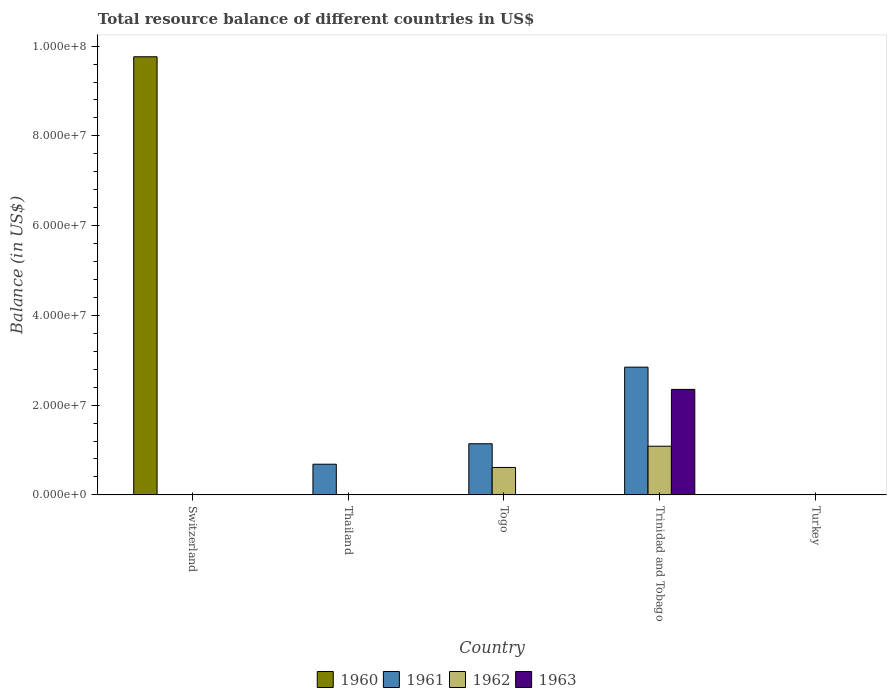How many different coloured bars are there?
Make the answer very short. 4. Are the number of bars per tick equal to the number of legend labels?
Give a very brief answer. No. How many bars are there on the 3rd tick from the left?
Offer a terse response. 2. How many bars are there on the 1st tick from the right?
Your answer should be compact. 0. What is the label of the 4th group of bars from the left?
Your response must be concise. Trinidad and Tobago. In how many cases, is the number of bars for a given country not equal to the number of legend labels?
Offer a very short reply. 5. What is the total resource balance in 1962 in Turkey?
Keep it short and to the point. 0. Across all countries, what is the maximum total resource balance in 1961?
Keep it short and to the point. 2.85e+07. In which country was the total resource balance in 1962 maximum?
Make the answer very short. Trinidad and Tobago. What is the total total resource balance in 1963 in the graph?
Offer a very short reply. 2.35e+07. What is the difference between the total resource balance in 1962 in Togo and that in Trinidad and Tobago?
Your answer should be very brief. -4.74e+06. What is the average total resource balance in 1961 per country?
Ensure brevity in your answer.  9.34e+06. What is the difference between the highest and the second highest total resource balance in 1961?
Provide a short and direct response. -4.56e+06. What is the difference between the highest and the lowest total resource balance in 1962?
Ensure brevity in your answer.  1.08e+07. Is it the case that in every country, the sum of the total resource balance in 1961 and total resource balance in 1963 is greater than the sum of total resource balance in 1962 and total resource balance in 1960?
Provide a short and direct response. No. Is it the case that in every country, the sum of the total resource balance in 1960 and total resource balance in 1961 is greater than the total resource balance in 1963?
Provide a short and direct response. No. How many bars are there?
Your answer should be very brief. 7. How many countries are there in the graph?
Ensure brevity in your answer.  5. Are the values on the major ticks of Y-axis written in scientific E-notation?
Your response must be concise. Yes. Does the graph contain grids?
Your answer should be compact. No. How many legend labels are there?
Give a very brief answer. 4. How are the legend labels stacked?
Your response must be concise. Horizontal. What is the title of the graph?
Your answer should be very brief. Total resource balance of different countries in US$. What is the label or title of the X-axis?
Offer a terse response. Country. What is the label or title of the Y-axis?
Your answer should be very brief. Balance (in US$). What is the Balance (in US$) in 1960 in Switzerland?
Give a very brief answer. 9.76e+07. What is the Balance (in US$) of 1961 in Switzerland?
Provide a succinct answer. 0. What is the Balance (in US$) of 1961 in Thailand?
Your answer should be very brief. 6.84e+06. What is the Balance (in US$) of 1961 in Togo?
Your answer should be compact. 1.14e+07. What is the Balance (in US$) in 1962 in Togo?
Provide a succinct answer. 6.11e+06. What is the Balance (in US$) of 1961 in Trinidad and Tobago?
Make the answer very short. 2.85e+07. What is the Balance (in US$) of 1962 in Trinidad and Tobago?
Your response must be concise. 1.08e+07. What is the Balance (in US$) of 1963 in Trinidad and Tobago?
Your answer should be compact. 2.35e+07. What is the Balance (in US$) of 1961 in Turkey?
Offer a very short reply. 0. What is the Balance (in US$) in 1963 in Turkey?
Make the answer very short. 0. Across all countries, what is the maximum Balance (in US$) of 1960?
Your answer should be very brief. 9.76e+07. Across all countries, what is the maximum Balance (in US$) of 1961?
Provide a short and direct response. 2.85e+07. Across all countries, what is the maximum Balance (in US$) in 1962?
Provide a short and direct response. 1.08e+07. Across all countries, what is the maximum Balance (in US$) in 1963?
Offer a terse response. 2.35e+07. Across all countries, what is the minimum Balance (in US$) of 1960?
Give a very brief answer. 0. Across all countries, what is the minimum Balance (in US$) in 1962?
Your answer should be very brief. 0. What is the total Balance (in US$) of 1960 in the graph?
Your answer should be compact. 9.76e+07. What is the total Balance (in US$) in 1961 in the graph?
Provide a succinct answer. 4.67e+07. What is the total Balance (in US$) in 1962 in the graph?
Your answer should be very brief. 1.70e+07. What is the total Balance (in US$) of 1963 in the graph?
Make the answer very short. 2.35e+07. What is the difference between the Balance (in US$) of 1961 in Thailand and that in Togo?
Offer a terse response. -4.56e+06. What is the difference between the Balance (in US$) of 1961 in Thailand and that in Trinidad and Tobago?
Your answer should be very brief. -2.16e+07. What is the difference between the Balance (in US$) in 1961 in Togo and that in Trinidad and Tobago?
Provide a succinct answer. -1.71e+07. What is the difference between the Balance (in US$) in 1962 in Togo and that in Trinidad and Tobago?
Keep it short and to the point. -4.74e+06. What is the difference between the Balance (in US$) in 1960 in Switzerland and the Balance (in US$) in 1961 in Thailand?
Give a very brief answer. 9.08e+07. What is the difference between the Balance (in US$) of 1960 in Switzerland and the Balance (in US$) of 1961 in Togo?
Ensure brevity in your answer.  8.62e+07. What is the difference between the Balance (in US$) of 1960 in Switzerland and the Balance (in US$) of 1962 in Togo?
Provide a succinct answer. 9.15e+07. What is the difference between the Balance (in US$) of 1960 in Switzerland and the Balance (in US$) of 1961 in Trinidad and Tobago?
Make the answer very short. 6.92e+07. What is the difference between the Balance (in US$) of 1960 in Switzerland and the Balance (in US$) of 1962 in Trinidad and Tobago?
Your answer should be very brief. 8.68e+07. What is the difference between the Balance (in US$) in 1960 in Switzerland and the Balance (in US$) in 1963 in Trinidad and Tobago?
Your response must be concise. 7.41e+07. What is the difference between the Balance (in US$) of 1961 in Thailand and the Balance (in US$) of 1962 in Togo?
Give a very brief answer. 7.25e+05. What is the difference between the Balance (in US$) in 1961 in Thailand and the Balance (in US$) in 1962 in Trinidad and Tobago?
Your answer should be very brief. -4.01e+06. What is the difference between the Balance (in US$) in 1961 in Thailand and the Balance (in US$) in 1963 in Trinidad and Tobago?
Offer a very short reply. -1.67e+07. What is the difference between the Balance (in US$) in 1961 in Togo and the Balance (in US$) in 1962 in Trinidad and Tobago?
Provide a succinct answer. 5.50e+05. What is the difference between the Balance (in US$) of 1961 in Togo and the Balance (in US$) of 1963 in Trinidad and Tobago?
Make the answer very short. -1.21e+07. What is the difference between the Balance (in US$) of 1962 in Togo and the Balance (in US$) of 1963 in Trinidad and Tobago?
Give a very brief answer. -1.74e+07. What is the average Balance (in US$) in 1960 per country?
Provide a succinct answer. 1.95e+07. What is the average Balance (in US$) in 1961 per country?
Provide a short and direct response. 9.34e+06. What is the average Balance (in US$) of 1962 per country?
Your answer should be compact. 3.39e+06. What is the average Balance (in US$) in 1963 per country?
Your answer should be compact. 4.70e+06. What is the difference between the Balance (in US$) of 1961 and Balance (in US$) of 1962 in Togo?
Ensure brevity in your answer.  5.29e+06. What is the difference between the Balance (in US$) of 1961 and Balance (in US$) of 1962 in Trinidad and Tobago?
Your answer should be compact. 1.76e+07. What is the difference between the Balance (in US$) of 1961 and Balance (in US$) of 1963 in Trinidad and Tobago?
Provide a short and direct response. 4.96e+06. What is the difference between the Balance (in US$) in 1962 and Balance (in US$) in 1963 in Trinidad and Tobago?
Your response must be concise. -1.27e+07. What is the ratio of the Balance (in US$) of 1961 in Thailand to that in Togo?
Your answer should be compact. 0.6. What is the ratio of the Balance (in US$) in 1961 in Thailand to that in Trinidad and Tobago?
Keep it short and to the point. 0.24. What is the ratio of the Balance (in US$) in 1961 in Togo to that in Trinidad and Tobago?
Ensure brevity in your answer.  0.4. What is the ratio of the Balance (in US$) in 1962 in Togo to that in Trinidad and Tobago?
Provide a succinct answer. 0.56. What is the difference between the highest and the second highest Balance (in US$) of 1961?
Provide a succinct answer. 1.71e+07. What is the difference between the highest and the lowest Balance (in US$) in 1960?
Ensure brevity in your answer.  9.76e+07. What is the difference between the highest and the lowest Balance (in US$) of 1961?
Offer a very short reply. 2.85e+07. What is the difference between the highest and the lowest Balance (in US$) of 1962?
Ensure brevity in your answer.  1.08e+07. What is the difference between the highest and the lowest Balance (in US$) of 1963?
Provide a succinct answer. 2.35e+07. 